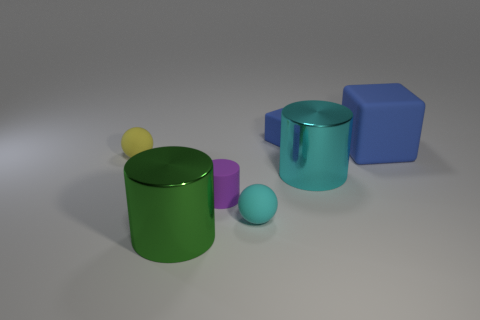How many other things are the same material as the big blue thing?
Give a very brief answer. 4. There is another blue rubber thing that is the same shape as the tiny blue rubber thing; what size is it?
Offer a terse response. Large. What material is the blue object that is in front of the small object behind the block that is right of the cyan cylinder?
Your answer should be very brief. Rubber. Is there a rubber ball?
Give a very brief answer. Yes. Do the large rubber cube and the rubber object behind the big rubber cube have the same color?
Offer a very short reply. Yes. The rubber cylinder is what color?
Offer a terse response. Purple. Are there any other things that have the same shape as the yellow rubber thing?
Your answer should be compact. Yes. There is another rubber thing that is the same shape as the tiny cyan rubber thing; what is its color?
Your answer should be compact. Yellow. Do the large blue thing and the tiny cyan matte thing have the same shape?
Your answer should be very brief. No. What number of spheres are either green things or purple matte objects?
Give a very brief answer. 0. 